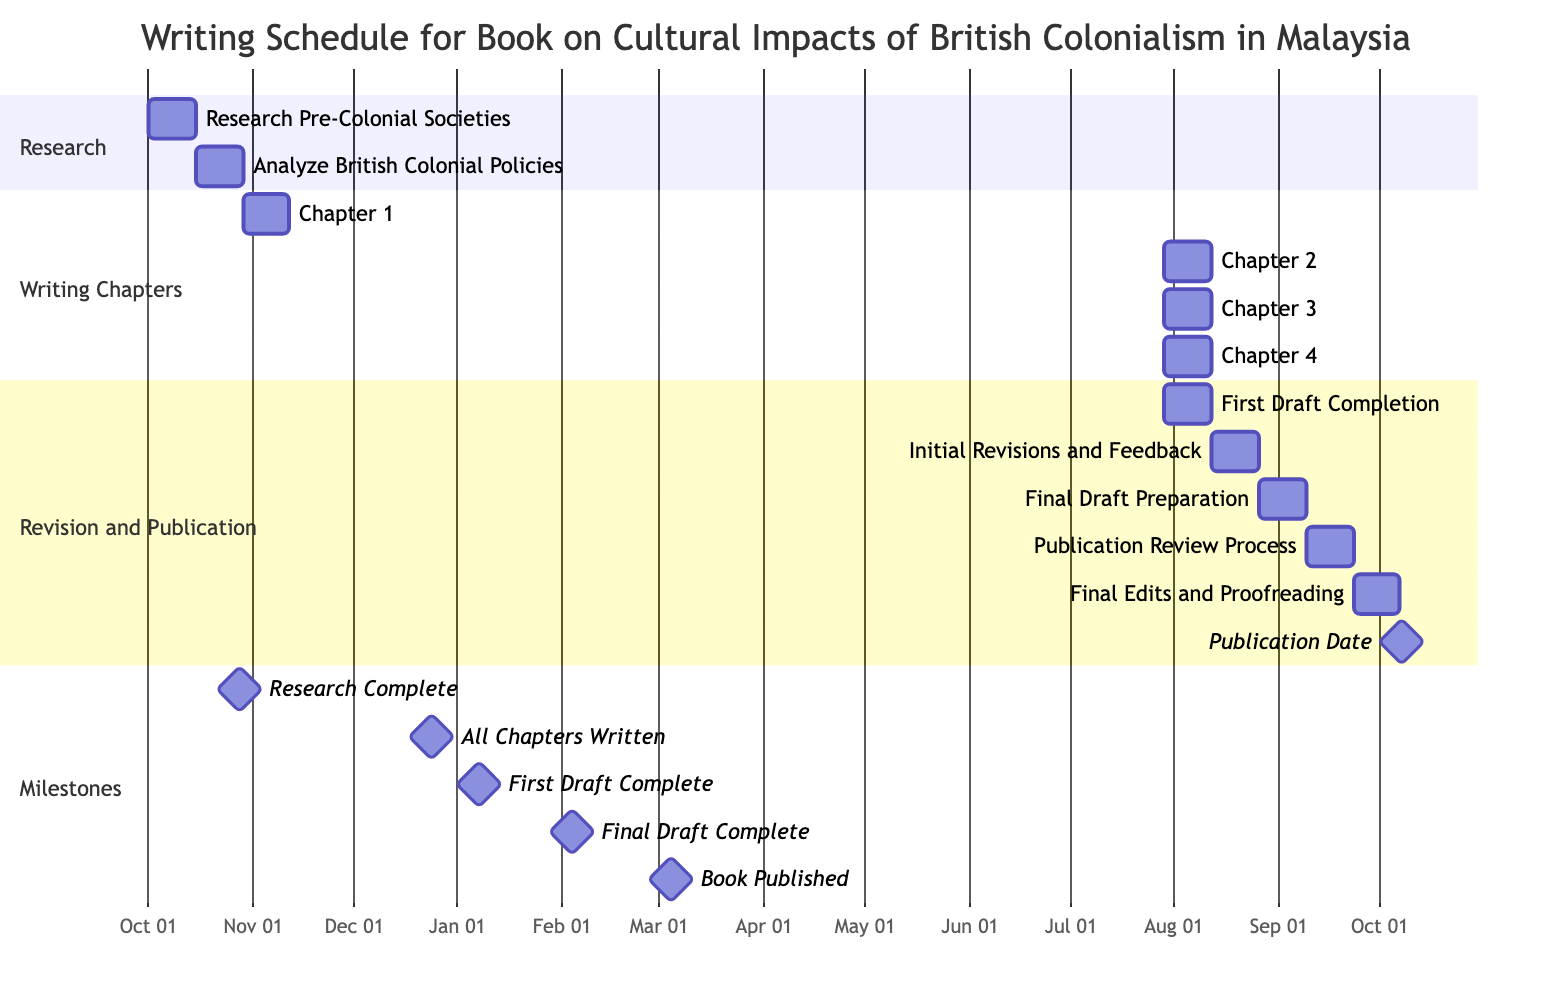What is the duration for "Research Pre-Colonial Societies"? The task "Research Pre-Colonial Societies" starts on October 1, 2023, and ends on October 14, 2023, which is a total of 14 days.
Answer: 14 days What comes immediately after "Chapter 3: Economic Changes Under Colonialism"? After "Chapter 3: Economic Changes Under Colonialism," the next task is "Chapter 4: Cultural Impacts and Interactions," which follows sequentially.
Answer: Chapter 4: Cultural Impacts and Interactions How many chapters are included in the writing schedule? The writing schedule includes a total of 4 chapters, as listed under the "Writing Chapters" section.
Answer: 4 chapters When is the first draft scheduled to be completed? The "First Draft Completion" is scheduled to end on January 7, 2024, following all previous writing tasks.
Answer: January 7, 2024 What milestone marks the completion of the research phase? The milestone for research completion is marked on October 28, 2023, which reflects the end date of "Analyze British Colonial Policies."
Answer: October 28, 2023 Which task starts after "Initial Revisions and Feedback"? The task that starts after "Initial Revisions and Feedback" is "Final Draft Preparation," which continues the workflow of revisions leading to the final draft.
Answer: Final Draft Preparation What is the total duration for the revision process? The revision process consists of several tasks: "First Draft Completion," "Initial Revisions and Feedback," "Final Draft Preparation," "Publication Review Process," and "Final Edits and Proofreading," each lasting 14 days, resulting in a total of 70 days for revisions.
Answer: 70 days When is the publication date scheduled? The "Publication Date" is set for March 4, 2024, marking the finalization of the entire writing and revising process.
Answer: March 4, 2024 Which section includes the task for "Final Edits and Proofreading"? The task "Final Edits and Proofreading" is included in the "Revision and Publication" section, which encompasses the final stages of the writing schedule.
Answer: Revision and Publication 